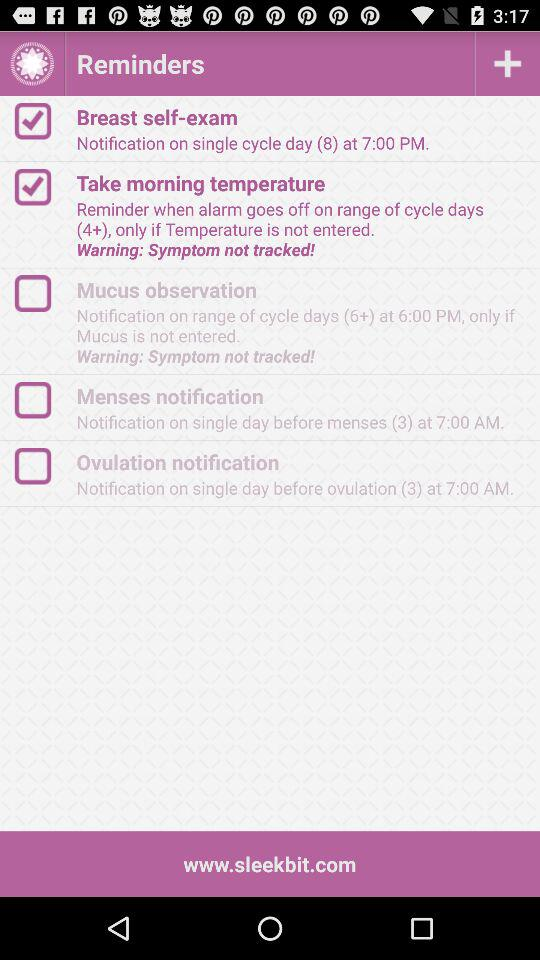What is the status of "Breast self-exam"? The status of "Breast self-exam" is "on". 